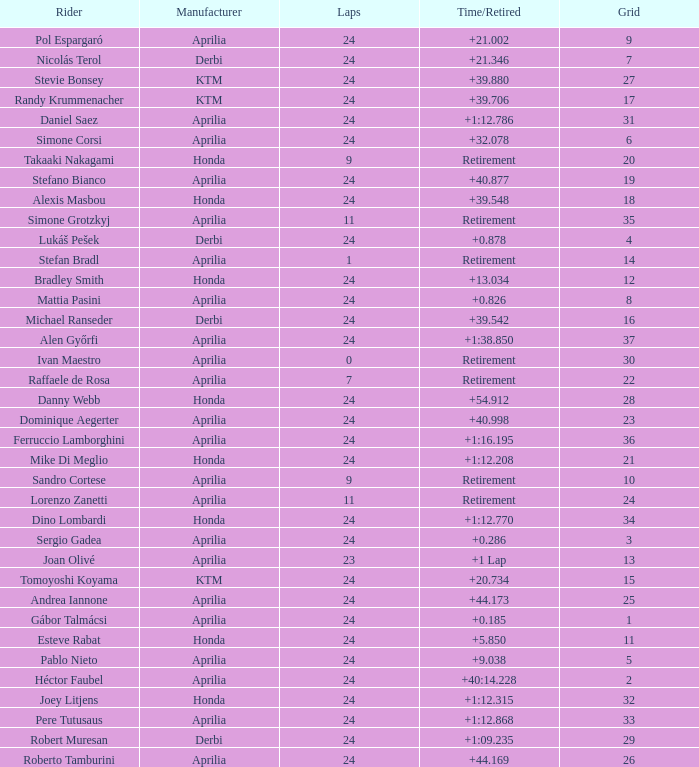How many grids have more than 24 laps with a time/retired of +1:12.208? None. 